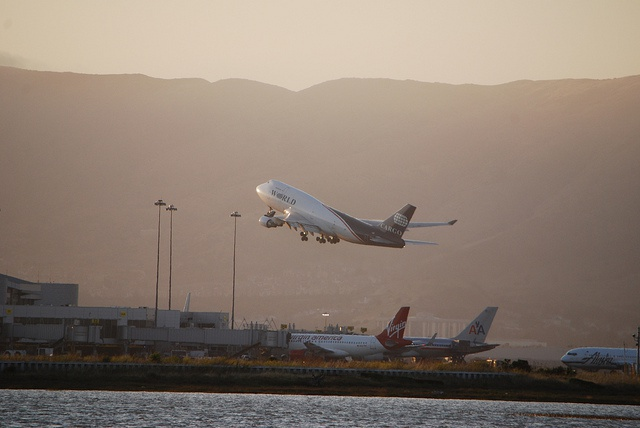Describe the objects in this image and their specific colors. I can see airplane in tan, gray, black, and maroon tones, airplane in tan, gray, and black tones, and airplane in tan, black, gray, and darkblue tones in this image. 